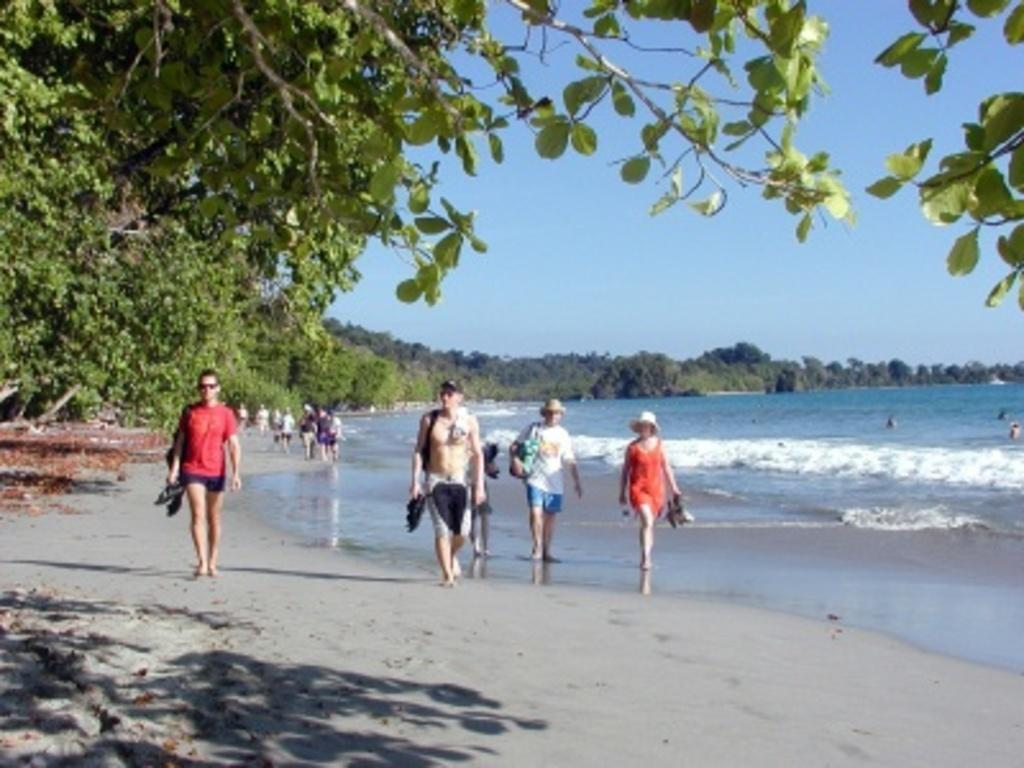What are the people in the image doing? The people in the image are walking. What type of natural elements can be seen in the image? Trees and water are present in the image. What is visible at the top of the image? The sky is visible at the top of the image. How many beds can be seen in the image? There are no beds present in the image. Is there a brother accompanying the people in the image? The provided facts do not mention any siblings or family members, so it cannot be determined if a brother is present in the image. 